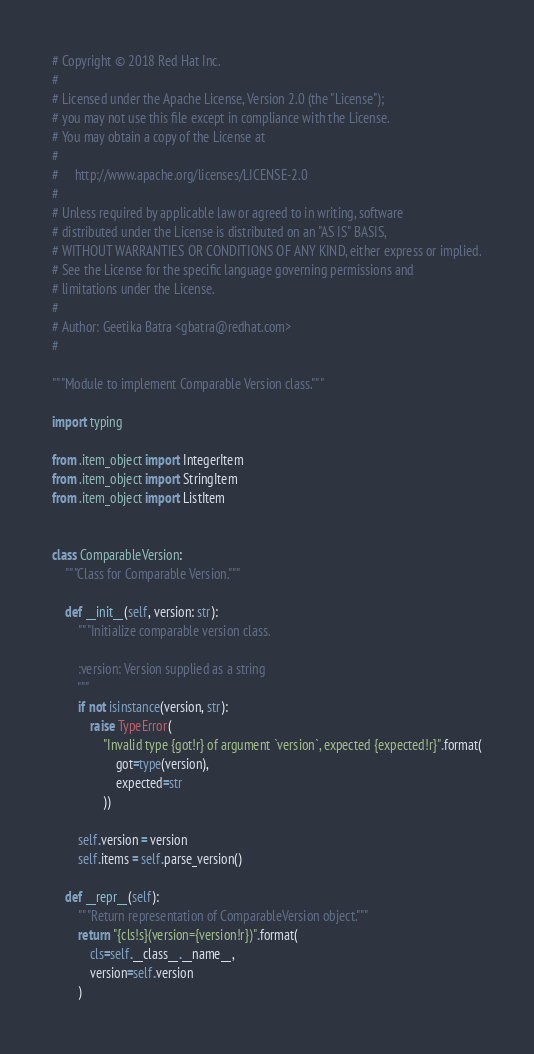Convert code to text. <code><loc_0><loc_0><loc_500><loc_500><_Python_># Copyright © 2018 Red Hat Inc.
#
# Licensed under the Apache License, Version 2.0 (the "License");
# you may not use this file except in compliance with the License.
# You may obtain a copy of the License at
#
#     http://www.apache.org/licenses/LICENSE-2.0
#
# Unless required by applicable law or agreed to in writing, software
# distributed under the License is distributed on an "AS IS" BASIS,
# WITHOUT WARRANTIES OR CONDITIONS OF ANY KIND, either express or implied.
# See the License for the specific language governing permissions and
# limitations under the License.
#
# Author: Geetika Batra <gbatra@redhat.com>
#

"""Module to implement Comparable Version class."""

import typing

from .item_object import IntegerItem
from .item_object import StringItem
from .item_object import ListItem


class ComparableVersion:
    """Class for Comparable Version."""

    def __init__(self, version: str):
        """Initialize comparable version class.

        :version: Version supplied as a string
        """
        if not isinstance(version, str):
            raise TypeError(
                "Invalid type {got!r} of argument `version`, expected {expected!r}".format(
                    got=type(version),
                    expected=str
                ))

        self.version = version
        self.items = self.parse_version()

    def __repr__(self):
        """Return representation of ComparableVersion object."""
        return "{cls!s}(version={version!r})".format(
            cls=self.__class__.__name__,
            version=self.version
        )
</code> 